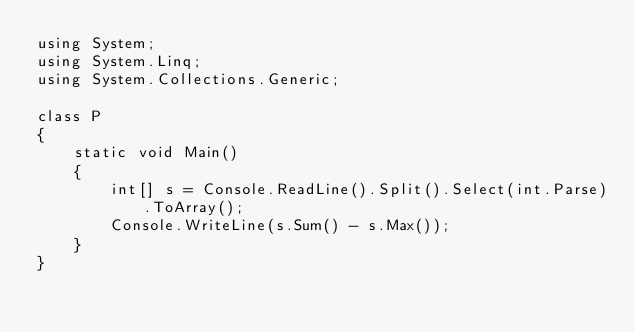Convert code to text. <code><loc_0><loc_0><loc_500><loc_500><_C#_>using System;
using System.Linq;
using System.Collections.Generic;

class P
{
    static void Main()
    {
        int[] s = Console.ReadLine().Split().Select(int.Parse).ToArray();
        Console.WriteLine(s.Sum() - s.Max());
    }
}</code> 